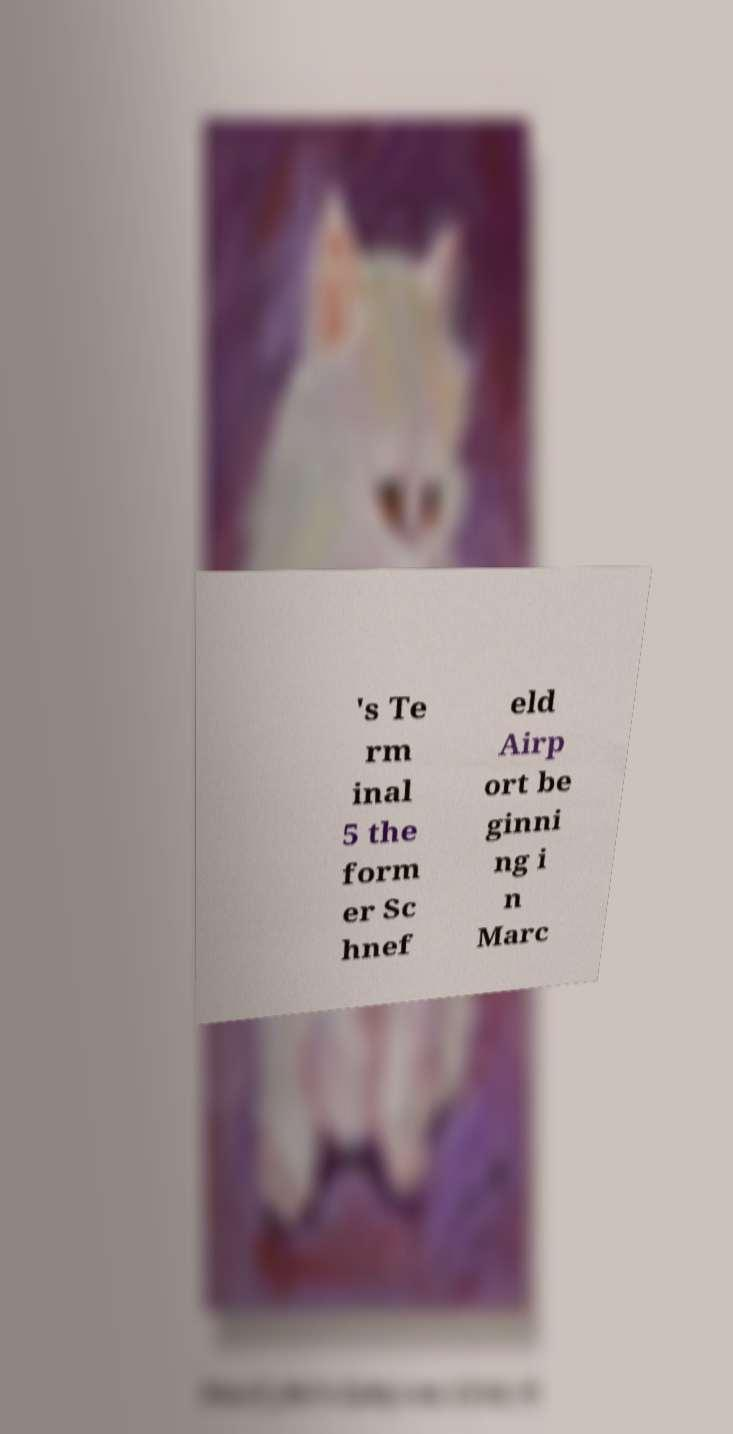Can you accurately transcribe the text from the provided image for me? 's Te rm inal 5 the form er Sc hnef eld Airp ort be ginni ng i n Marc 